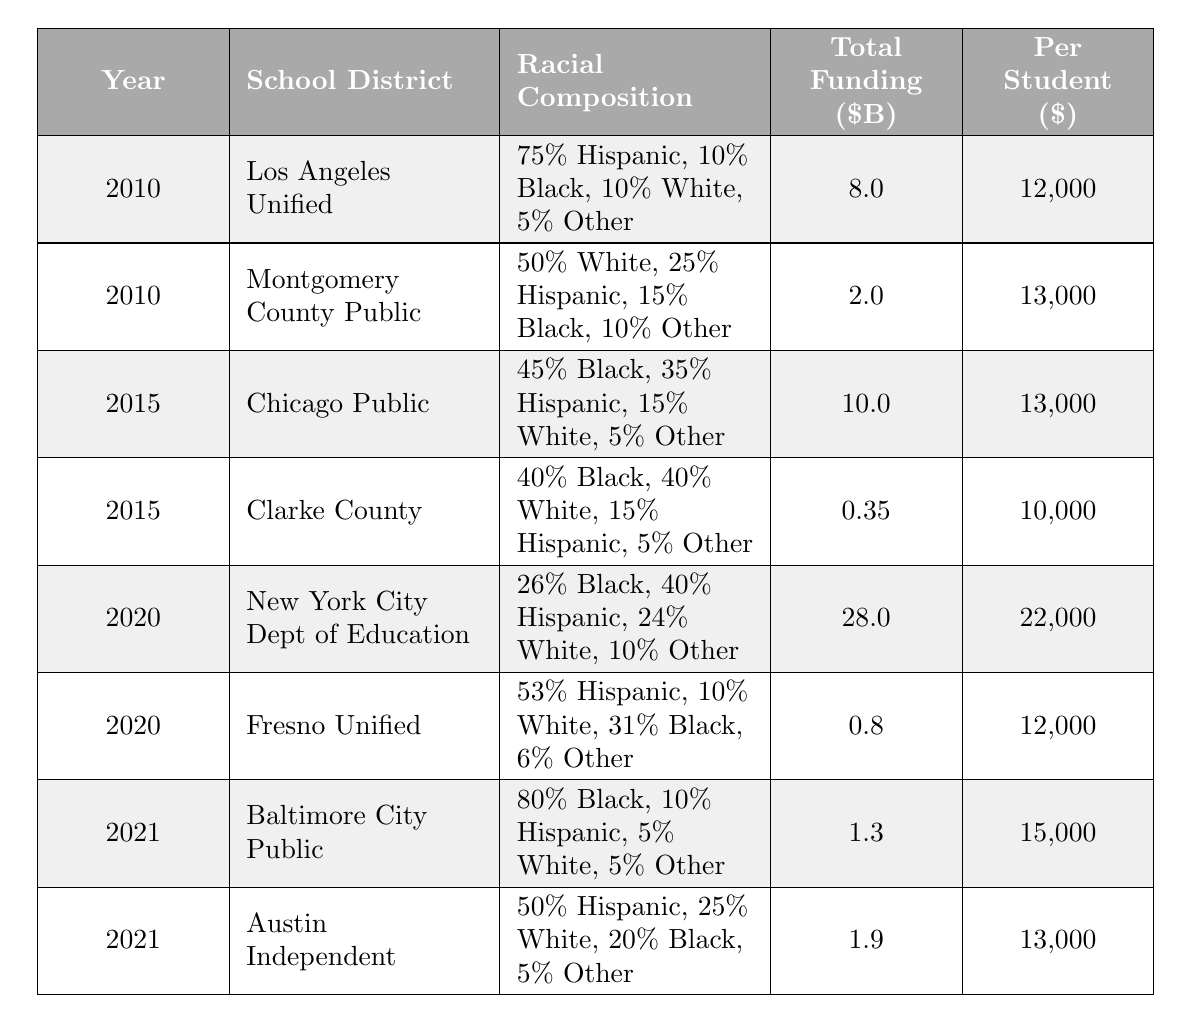What was the total funding for Los Angeles Unified School District in 2010? The table shows that for the year 2010, Los Angeles Unified School District had a total funding of $8 billion.
Answer: 8 billion What is the per student funding for Chicago Public Schools in 2015? Looking at the 2015 row for Chicago Public Schools, the per student funding is listed as $13,000.
Answer: 13,000 Which school district had the highest total funding in 2020? The total funding for New York City Department of Education in 2020 is $28 billion, which is the highest compared to others listed for that year.
Answer: New York City Department of Education Was the racial composition of Baltimore City Public Schools predominantly Black in 2021? Yes, the table indicates that 80% of the racial composition for Baltimore City Public Schools in 2021 is Black, confirming a predominantly Black demographic.
Answer: Yes What is the difference in per student funding between Montgomery County Public Schools in 2010 and Clarke County School District in 2015? Montgomery County's per student funding is $13,000 and Clarke County's is $10,000. The difference is $13,000 - $10,000 = $3,000.
Answer: 3,000 What is the average total funding for school districts in 2015? The total funding for both districts in 2015 is $10 billion (Chicago Public Schools) + $0.35 billion (Clarke County School District) = $10.35 billion. Dividing by 2 gives an average of $10.35 billion / 2 = $5.175 billion.
Answer: 5.175 billion Did any school district have per student funding below $12,000 in 2021? According to the table, both Baltimore City Public Schools ($15,000) and Austin Independent School District ($13,000) exceeded $12,000, thus no district was below that amount in 2021.
Answer: No How does the total funding for Fresno Unified School District in 2020 compare to the funding for Clarke County School District in 2015? Fresno Unified School District had total funding of $0.8 billion in 2020, while Clarke County School District had $0.35 billion in 2015. Comparing these, $0.8 billion is greater than $0.35 billion.
Answer: Fresno Unified is greater What is the trend in per student funding from 2010 to 2021 for the districts in this table? In 2010 the per student funding ranged from $12,000 to $13,000, in 2015 it was between $10,000 and $13,000, in 2020 it rose to $12,000 and $22,000, and in 2021 it was between $13,000 and $15,000. Overall, there is a general upward trend in per student funding from 2010 to 2021.
Answer: Upward trend 